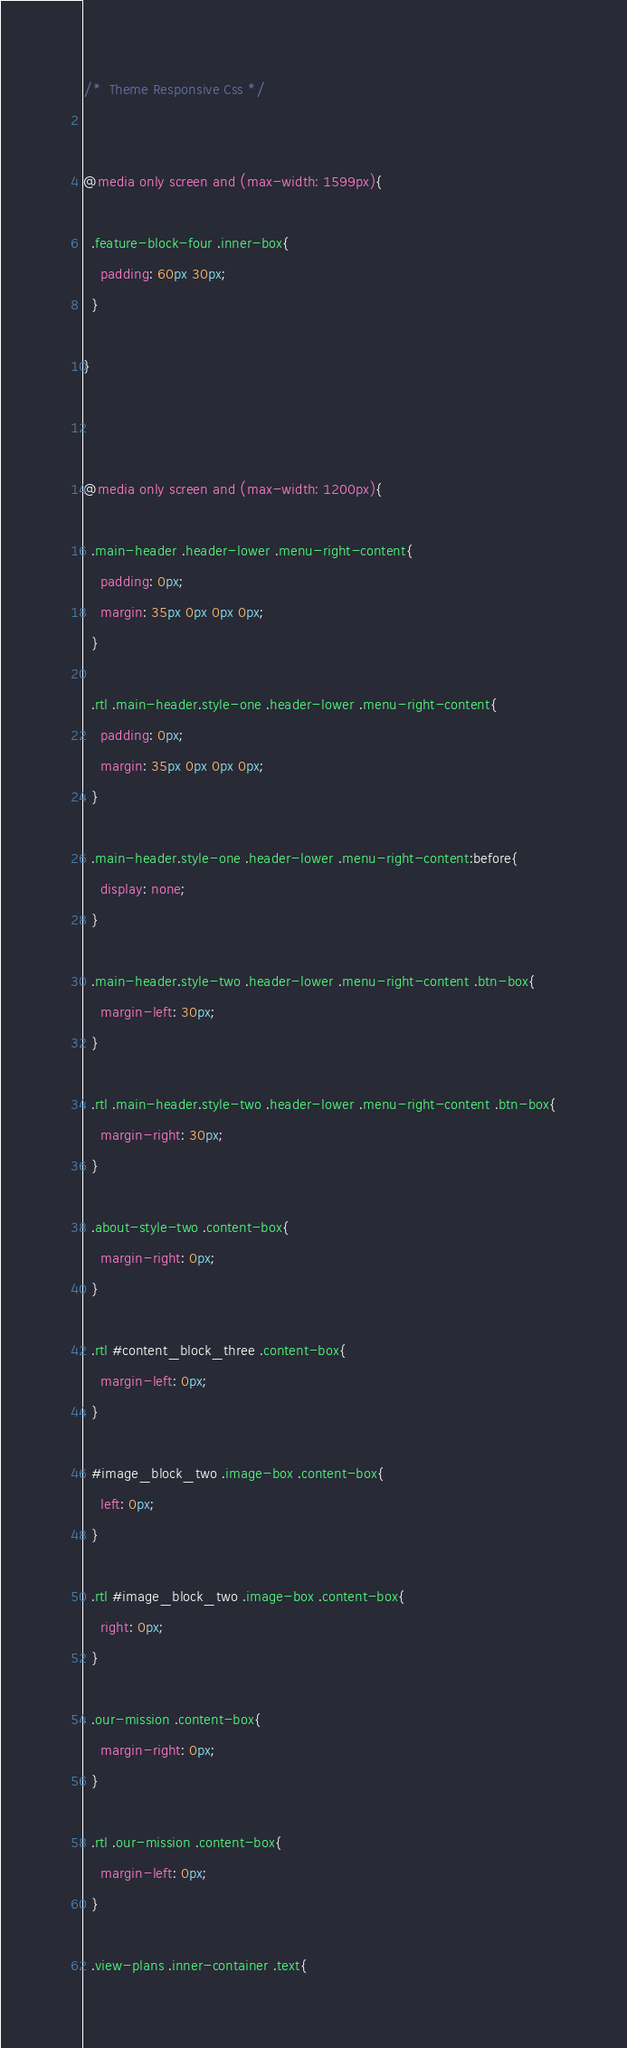<code> <loc_0><loc_0><loc_500><loc_500><_CSS_>/*  Theme Responsive Css */


@media only screen and (max-width: 1599px){

  .feature-block-four .inner-box{
    padding: 60px 30px;
  }

}



@media only screen and (max-width: 1200px){

  .main-header .header-lower .menu-right-content{
    padding: 0px;
    margin: 35px 0px 0px 0px;
  }

  .rtl .main-header.style-one .header-lower .menu-right-content{
    padding: 0px;
    margin: 35px 0px 0px 0px;
  }

  .main-header.style-one .header-lower .menu-right-content:before{
    display: none;
  }

  .main-header.style-two .header-lower .menu-right-content .btn-box{
    margin-left: 30px;
  }

  .rtl .main-header.style-two .header-lower .menu-right-content .btn-box{
    margin-right: 30px;
  }

  .about-style-two .content-box{
    margin-right: 0px;
  }

  .rtl #content_block_three .content-box{
    margin-left: 0px;
  }

  #image_block_two .image-box .content-box{
    left: 0px;
  }

  .rtl #image_block_two .image-box .content-box{
    right: 0px;
  }

  .our-mission .content-box{
    margin-right: 0px;
  }

  .rtl .our-mission .content-box{
    margin-left: 0px;
  }

  .view-plans .inner-container .text{</code> 